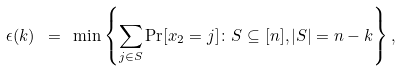<formula> <loc_0><loc_0><loc_500><loc_500>\epsilon ( k ) \ = \ \min \left \{ \sum _ { j \in S } \Pr [ x _ { 2 } = j ] \colon S \subseteq [ n ] , | S | = n - k \right \} ,</formula> 